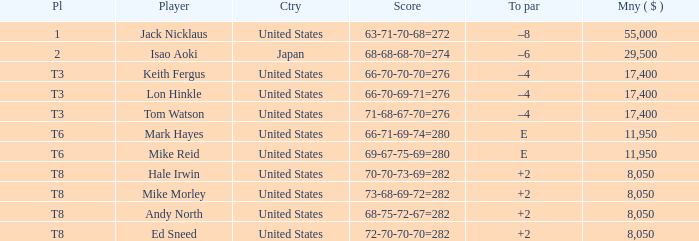What player has money larger than 11,950 and is placed in t8 and has the score of 73-68-69-72=282? None. 